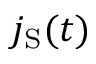Convert formula to latex. <formula><loc_0><loc_0><loc_500><loc_500>j _ { S } ( t )</formula> 